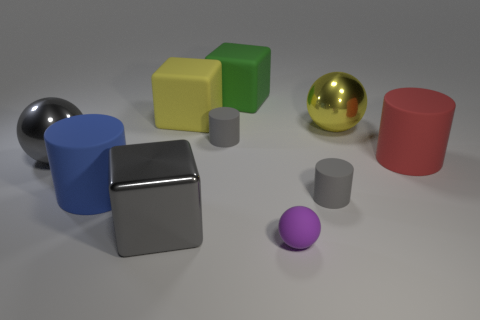Subtract all big matte blocks. How many blocks are left? 1 Subtract all cyan cubes. How many gray cylinders are left? 2 Subtract 1 blocks. How many blocks are left? 2 Subtract all purple balls. How many balls are left? 2 Subtract all cubes. How many objects are left? 7 Subtract 0 yellow cylinders. How many objects are left? 10 Subtract all blue balls. Subtract all blue blocks. How many balls are left? 3 Subtract all rubber spheres. Subtract all big gray metallic spheres. How many objects are left? 8 Add 1 rubber cylinders. How many rubber cylinders are left? 5 Add 9 large blue rubber things. How many large blue rubber things exist? 10 